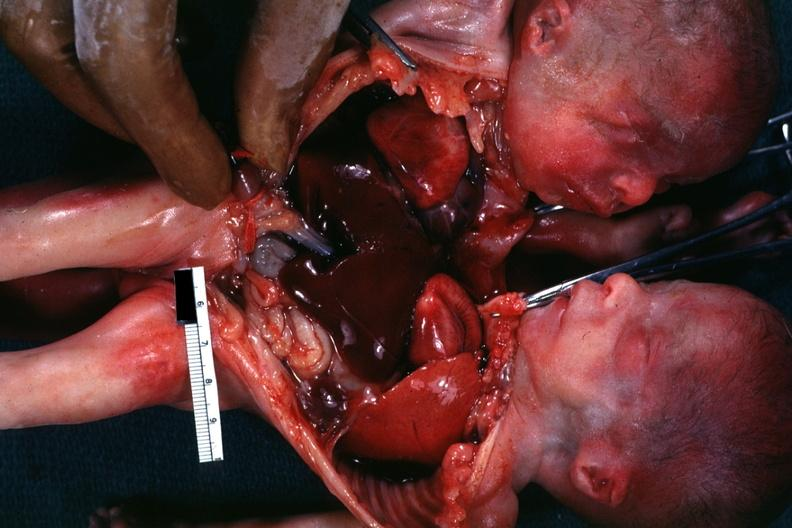what is present?
Answer the question using a single word or phrase. Siamese twins 